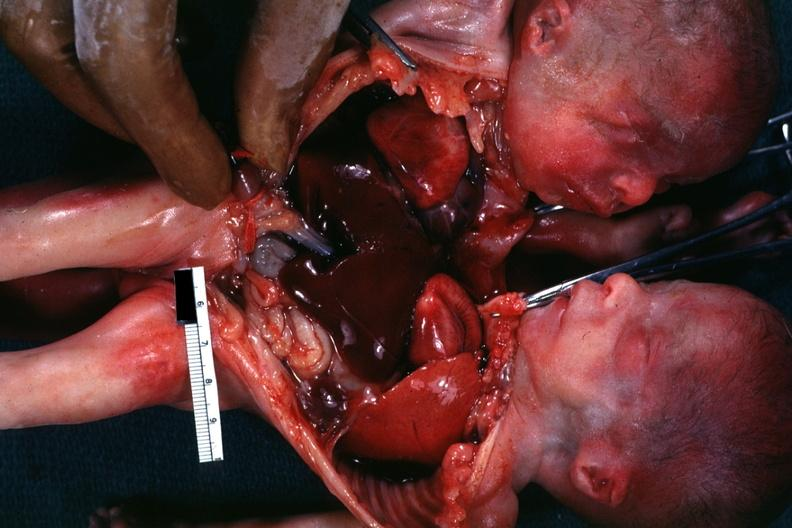what is present?
Answer the question using a single word or phrase. Siamese twins 